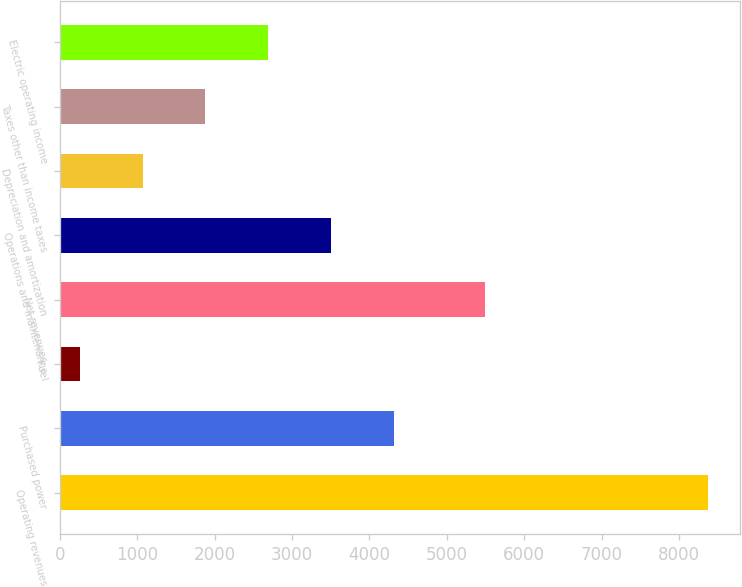<chart> <loc_0><loc_0><loc_500><loc_500><bar_chart><fcel>Operating revenues<fcel>Purchased power<fcel>Fuel<fcel>Net revenues<fcel>Operations and maintenance<fcel>Depreciation and amortization<fcel>Taxes other than income taxes<fcel>Electric operating income<nl><fcel>8376<fcel>4316<fcel>256<fcel>5491<fcel>3504<fcel>1068<fcel>1880<fcel>2692<nl></chart> 